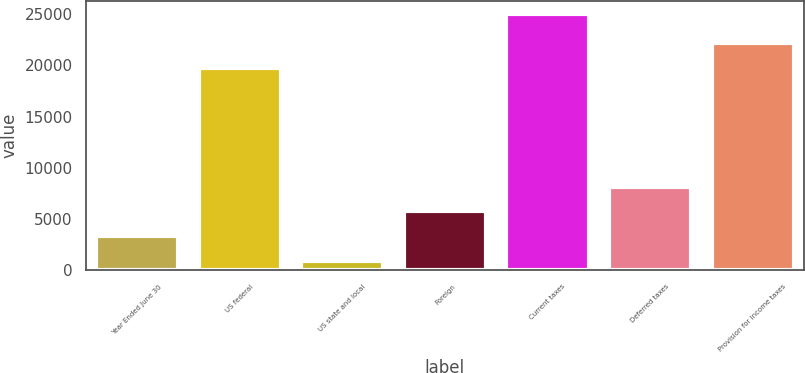Convert chart to OTSL. <chart><loc_0><loc_0><loc_500><loc_500><bar_chart><fcel>Year Ended June 30<fcel>US federal<fcel>US state and local<fcel>Foreign<fcel>Current taxes<fcel>Deferred taxes<fcel>Provision for income taxes<nl><fcel>3345.2<fcel>19764<fcel>934<fcel>5756.4<fcel>25046<fcel>8167.6<fcel>22175.2<nl></chart> 